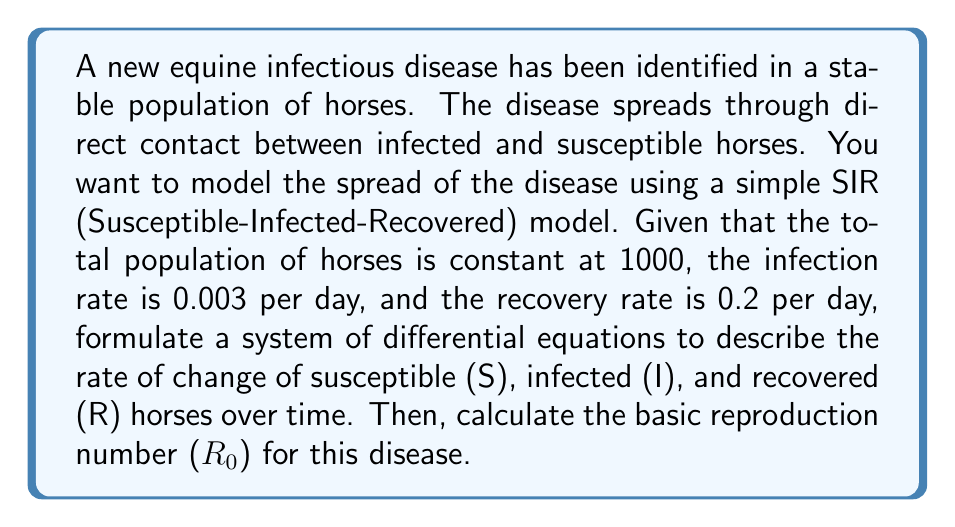Could you help me with this problem? Step 1: Formulate the SIR model differential equations

The SIR model consists of three differential equations:

$$\frac{dS}{dt} = -\beta SI$$
$$\frac{dI}{dt} = \beta SI - \gamma I$$
$$\frac{dR}{dt} = \gamma I$$

Where:
$S$ = number of susceptible horses
$I$ = number of infected horses
$R$ = number of recovered horses
$\beta$ = infection rate
$\gamma$ = recovery rate

Step 2: Substitute the given values

Total population: $N = S + I + R = 1000$
$\beta = 0.003$ per day
$\gamma = 0.2$ per day

The system of differential equations becomes:

$$\frac{dS}{dt} = -0.003SI$$
$$\frac{dI}{dt} = 0.003SI - 0.2I$$
$$\frac{dR}{dt} = 0.2I$$

Step 3: Calculate the basic reproduction number ($R_0$)

The basic reproduction number is defined as the average number of secondary infections caused by one infected individual in a completely susceptible population. It is calculated as:

$$R_0 = \frac{\beta N}{\gamma}$$

Substituting the values:

$$R_0 = \frac{0.003 \times 1000}{0.2} = \frac{3}{0.2} = 15$$
Answer: $R_0 = 15$ 